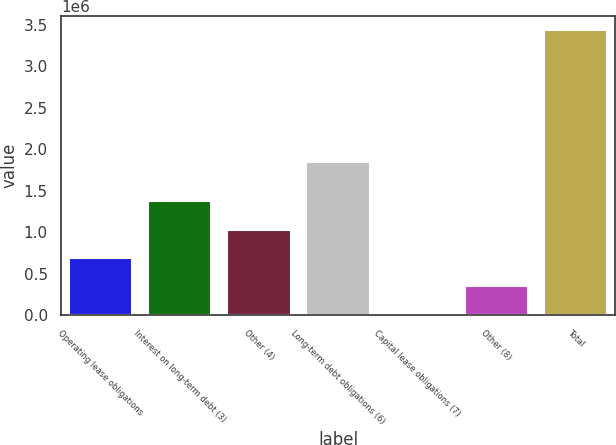Convert chart. <chart><loc_0><loc_0><loc_500><loc_500><bar_chart><fcel>Operating lease obligations<fcel>Interest on long-term debt (3)<fcel>Other (4)<fcel>Long-term debt obligations (6)<fcel>Capital lease obligations (7)<fcel>Other (8)<fcel>Total<nl><fcel>689572<fcel>1.37427e+06<fcel>1.03192e+06<fcel>1.84142e+06<fcel>4875<fcel>347223<fcel>3.42836e+06<nl></chart> 